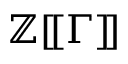<formula> <loc_0><loc_0><loc_500><loc_500>\mathbb { Z } [ \, [ \Gamma ] \, ]</formula> 